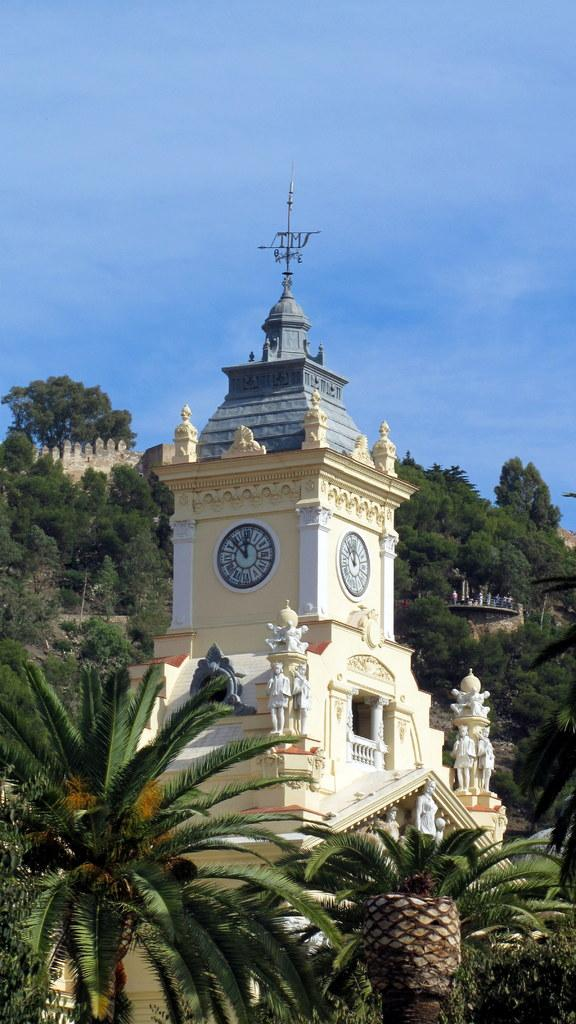What type of natural elements can be seen in the image? There are many trees in the image. What structure is located in the middle of the image? There is a cloakroom in the middle of the image. What is visible at the top of the image? The sky is visible at the top of the image. What type of artwork is near the building in the image? There are sculptures near the building in the image. What title is given to the liquid in the image? There is no liquid present in the image, so there is no title to be given. 